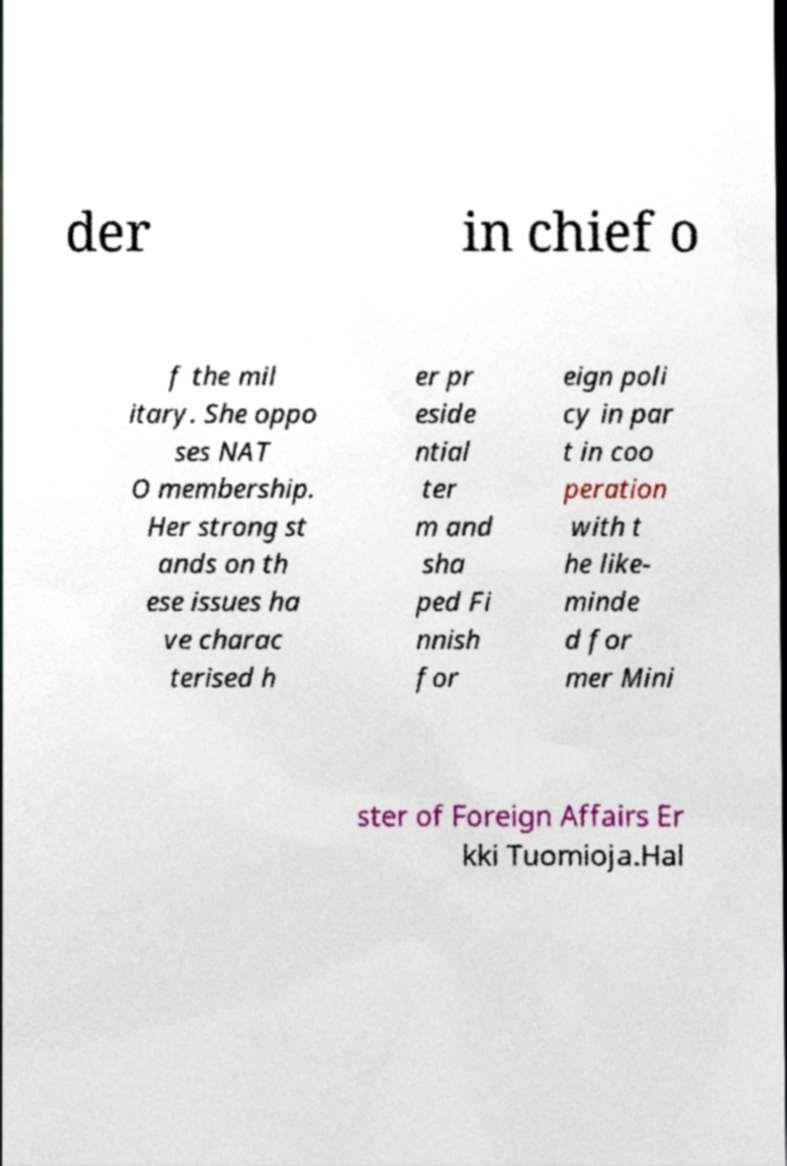Could you assist in decoding the text presented in this image and type it out clearly? der in chief o f the mil itary. She oppo ses NAT O membership. Her strong st ands on th ese issues ha ve charac terised h er pr eside ntial ter m and sha ped Fi nnish for eign poli cy in par t in coo peration with t he like- minde d for mer Mini ster of Foreign Affairs Er kki Tuomioja.Hal 